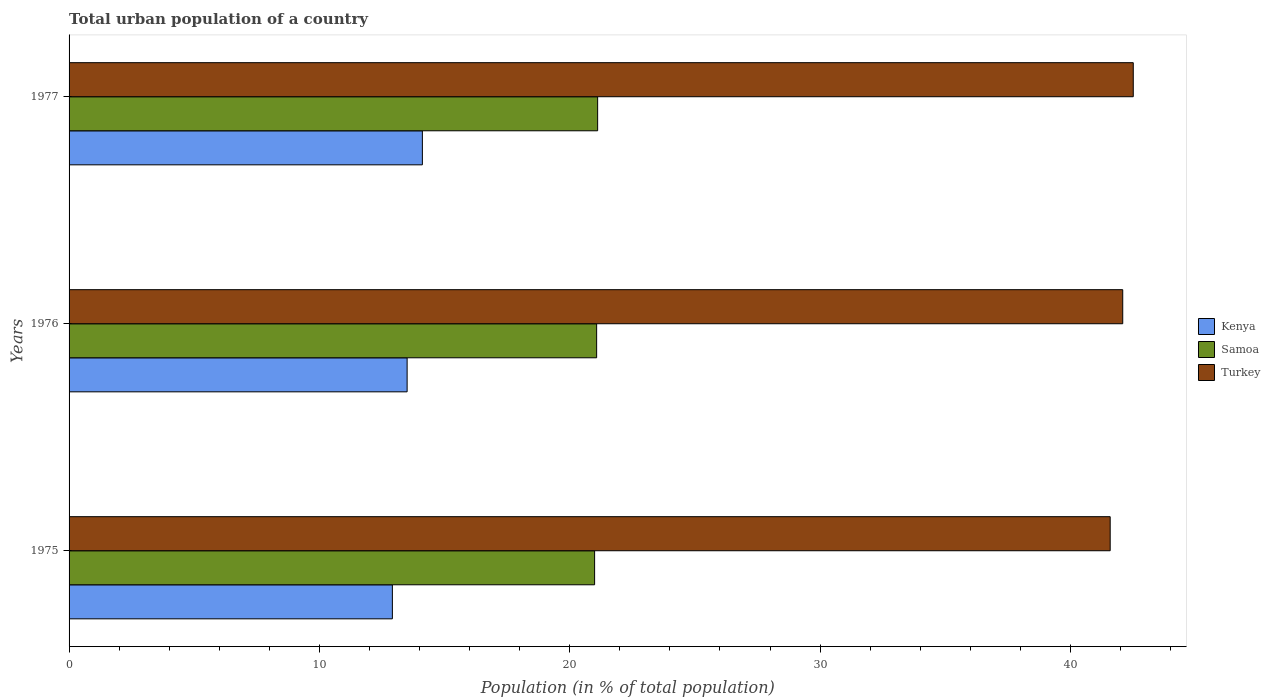How many different coloured bars are there?
Provide a short and direct response. 3. Are the number of bars per tick equal to the number of legend labels?
Offer a very short reply. Yes. Are the number of bars on each tick of the Y-axis equal?
Provide a short and direct response. Yes. How many bars are there on the 1st tick from the top?
Keep it short and to the point. 3. What is the label of the 2nd group of bars from the top?
Provide a succinct answer. 1976. In how many cases, is the number of bars for a given year not equal to the number of legend labels?
Provide a succinct answer. 0. What is the urban population in Turkey in 1975?
Keep it short and to the point. 41.59. Across all years, what is the maximum urban population in Samoa?
Your answer should be compact. 21.11. Across all years, what is the minimum urban population in Samoa?
Your response must be concise. 20.99. In which year was the urban population in Turkey maximum?
Your response must be concise. 1977. In which year was the urban population in Kenya minimum?
Provide a succinct answer. 1975. What is the total urban population in Kenya in the graph?
Keep it short and to the point. 40.53. What is the difference between the urban population in Turkey in 1975 and that in 1976?
Your answer should be very brief. -0.5. What is the difference between the urban population in Kenya in 1977 and the urban population in Turkey in 1976?
Offer a very short reply. -27.98. What is the average urban population in Turkey per year?
Ensure brevity in your answer.  42.06. In the year 1976, what is the difference between the urban population in Kenya and urban population in Turkey?
Offer a very short reply. -28.58. In how many years, is the urban population in Kenya greater than 14 %?
Offer a very short reply. 1. What is the ratio of the urban population in Kenya in 1976 to that in 1977?
Provide a succinct answer. 0.96. Is the difference between the urban population in Kenya in 1975 and 1976 greater than the difference between the urban population in Turkey in 1975 and 1976?
Ensure brevity in your answer.  No. What is the difference between the highest and the second highest urban population in Kenya?
Provide a short and direct response. 0.61. What is the difference between the highest and the lowest urban population in Turkey?
Your answer should be very brief. 0.92. In how many years, is the urban population in Samoa greater than the average urban population in Samoa taken over all years?
Provide a succinct answer. 2. What does the 2nd bar from the top in 1975 represents?
Provide a succinct answer. Samoa. What does the 2nd bar from the bottom in 1975 represents?
Offer a very short reply. Samoa. Is it the case that in every year, the sum of the urban population in Samoa and urban population in Kenya is greater than the urban population in Turkey?
Provide a succinct answer. No. How many bars are there?
Ensure brevity in your answer.  9. How many years are there in the graph?
Provide a succinct answer. 3. What is the difference between two consecutive major ticks on the X-axis?
Your answer should be very brief. 10. Are the values on the major ticks of X-axis written in scientific E-notation?
Provide a short and direct response. No. Does the graph contain grids?
Give a very brief answer. No. Where does the legend appear in the graph?
Provide a short and direct response. Center right. How are the legend labels stacked?
Your answer should be compact. Vertical. What is the title of the graph?
Give a very brief answer. Total urban population of a country. Does "New Caledonia" appear as one of the legend labels in the graph?
Your response must be concise. No. What is the label or title of the X-axis?
Provide a succinct answer. Population (in % of total population). What is the label or title of the Y-axis?
Provide a short and direct response. Years. What is the Population (in % of total population) of Kenya in 1975?
Offer a very short reply. 12.91. What is the Population (in % of total population) of Samoa in 1975?
Your answer should be very brief. 20.99. What is the Population (in % of total population) of Turkey in 1975?
Your response must be concise. 41.59. What is the Population (in % of total population) in Kenya in 1976?
Ensure brevity in your answer.  13.5. What is the Population (in % of total population) in Samoa in 1976?
Offer a very short reply. 21.07. What is the Population (in % of total population) of Turkey in 1976?
Your answer should be compact. 42.09. What is the Population (in % of total population) in Kenya in 1977?
Your answer should be compact. 14.11. What is the Population (in % of total population) in Samoa in 1977?
Keep it short and to the point. 21.11. What is the Population (in % of total population) in Turkey in 1977?
Keep it short and to the point. 42.51. Across all years, what is the maximum Population (in % of total population) of Kenya?
Offer a very short reply. 14.11. Across all years, what is the maximum Population (in % of total population) of Samoa?
Offer a very short reply. 21.11. Across all years, what is the maximum Population (in % of total population) of Turkey?
Make the answer very short. 42.51. Across all years, what is the minimum Population (in % of total population) of Kenya?
Your answer should be very brief. 12.91. Across all years, what is the minimum Population (in % of total population) of Samoa?
Provide a short and direct response. 20.99. Across all years, what is the minimum Population (in % of total population) in Turkey?
Give a very brief answer. 41.59. What is the total Population (in % of total population) of Kenya in the graph?
Keep it short and to the point. 40.53. What is the total Population (in % of total population) of Samoa in the graph?
Ensure brevity in your answer.  63.18. What is the total Population (in % of total population) in Turkey in the graph?
Give a very brief answer. 126.18. What is the difference between the Population (in % of total population) of Kenya in 1975 and that in 1976?
Provide a succinct answer. -0.59. What is the difference between the Population (in % of total population) in Samoa in 1975 and that in 1976?
Your answer should be very brief. -0.08. What is the difference between the Population (in % of total population) of Turkey in 1975 and that in 1976?
Keep it short and to the point. -0.5. What is the difference between the Population (in % of total population) of Kenya in 1975 and that in 1977?
Make the answer very short. -1.2. What is the difference between the Population (in % of total population) of Samoa in 1975 and that in 1977?
Make the answer very short. -0.12. What is the difference between the Population (in % of total population) in Turkey in 1975 and that in 1977?
Keep it short and to the point. -0.92. What is the difference between the Population (in % of total population) in Kenya in 1976 and that in 1977?
Your response must be concise. -0.61. What is the difference between the Population (in % of total population) of Samoa in 1976 and that in 1977?
Your response must be concise. -0.04. What is the difference between the Population (in % of total population) in Turkey in 1976 and that in 1977?
Your answer should be compact. -0.42. What is the difference between the Population (in % of total population) of Kenya in 1975 and the Population (in % of total population) of Samoa in 1976?
Your answer should be very brief. -8.16. What is the difference between the Population (in % of total population) of Kenya in 1975 and the Population (in % of total population) of Turkey in 1976?
Make the answer very short. -29.17. What is the difference between the Population (in % of total population) in Samoa in 1975 and the Population (in % of total population) in Turkey in 1976?
Provide a short and direct response. -21.09. What is the difference between the Population (in % of total population) of Kenya in 1975 and the Population (in % of total population) of Samoa in 1977?
Provide a short and direct response. -8.2. What is the difference between the Population (in % of total population) in Kenya in 1975 and the Population (in % of total population) in Turkey in 1977?
Offer a very short reply. -29.59. What is the difference between the Population (in % of total population) of Samoa in 1975 and the Population (in % of total population) of Turkey in 1977?
Offer a very short reply. -21.52. What is the difference between the Population (in % of total population) of Kenya in 1976 and the Population (in % of total population) of Samoa in 1977?
Offer a terse response. -7.61. What is the difference between the Population (in % of total population) of Kenya in 1976 and the Population (in % of total population) of Turkey in 1977?
Offer a terse response. -29. What is the difference between the Population (in % of total population) in Samoa in 1976 and the Population (in % of total population) in Turkey in 1977?
Give a very brief answer. -21.43. What is the average Population (in % of total population) in Kenya per year?
Offer a very short reply. 13.51. What is the average Population (in % of total population) in Samoa per year?
Offer a very short reply. 21.06. What is the average Population (in % of total population) in Turkey per year?
Your response must be concise. 42.06. In the year 1975, what is the difference between the Population (in % of total population) of Kenya and Population (in % of total population) of Samoa?
Keep it short and to the point. -8.08. In the year 1975, what is the difference between the Population (in % of total population) of Kenya and Population (in % of total population) of Turkey?
Ensure brevity in your answer.  -28.67. In the year 1975, what is the difference between the Population (in % of total population) in Samoa and Population (in % of total population) in Turkey?
Give a very brief answer. -20.59. In the year 1976, what is the difference between the Population (in % of total population) in Kenya and Population (in % of total population) in Samoa?
Keep it short and to the point. -7.57. In the year 1976, what is the difference between the Population (in % of total population) in Kenya and Population (in % of total population) in Turkey?
Offer a very short reply. -28.58. In the year 1976, what is the difference between the Population (in % of total population) in Samoa and Population (in % of total population) in Turkey?
Your answer should be very brief. -21.01. In the year 1977, what is the difference between the Population (in % of total population) in Kenya and Population (in % of total population) in Samoa?
Ensure brevity in your answer.  -7. In the year 1977, what is the difference between the Population (in % of total population) in Kenya and Population (in % of total population) in Turkey?
Make the answer very short. -28.4. In the year 1977, what is the difference between the Population (in % of total population) in Samoa and Population (in % of total population) in Turkey?
Offer a terse response. -21.39. What is the ratio of the Population (in % of total population) of Kenya in 1975 to that in 1976?
Your answer should be compact. 0.96. What is the ratio of the Population (in % of total population) of Samoa in 1975 to that in 1976?
Your answer should be very brief. 1. What is the ratio of the Population (in % of total population) of Kenya in 1975 to that in 1977?
Give a very brief answer. 0.92. What is the ratio of the Population (in % of total population) of Samoa in 1975 to that in 1977?
Offer a terse response. 0.99. What is the ratio of the Population (in % of total population) of Turkey in 1975 to that in 1977?
Offer a terse response. 0.98. What is the ratio of the Population (in % of total population) of Kenya in 1976 to that in 1977?
Ensure brevity in your answer.  0.96. What is the ratio of the Population (in % of total population) in Samoa in 1976 to that in 1977?
Offer a terse response. 1. What is the difference between the highest and the second highest Population (in % of total population) in Kenya?
Offer a very short reply. 0.61. What is the difference between the highest and the second highest Population (in % of total population) in Samoa?
Provide a short and direct response. 0.04. What is the difference between the highest and the second highest Population (in % of total population) of Turkey?
Ensure brevity in your answer.  0.42. What is the difference between the highest and the lowest Population (in % of total population) of Kenya?
Keep it short and to the point. 1.2. What is the difference between the highest and the lowest Population (in % of total population) in Samoa?
Provide a short and direct response. 0.12. What is the difference between the highest and the lowest Population (in % of total population) of Turkey?
Your answer should be compact. 0.92. 